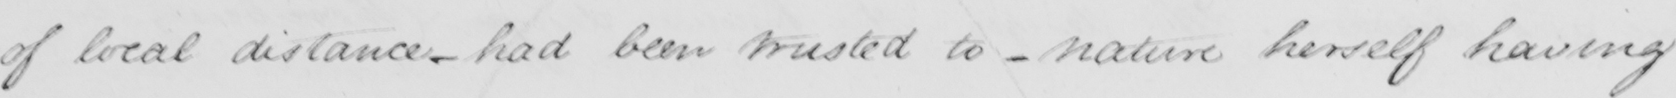Transcribe the text shown in this historical manuscript line. of local distance - had been trusted to - nature herself having 